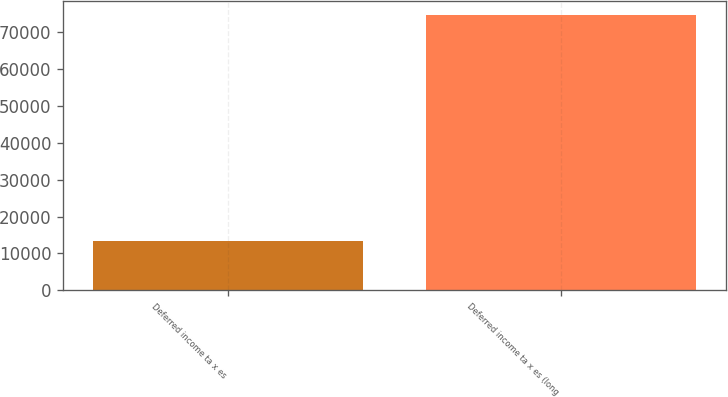Convert chart to OTSL. <chart><loc_0><loc_0><loc_500><loc_500><bar_chart><fcel>Deferred income ta x es<fcel>Deferred income ta x es (long<nl><fcel>13265<fcel>74589<nl></chart> 